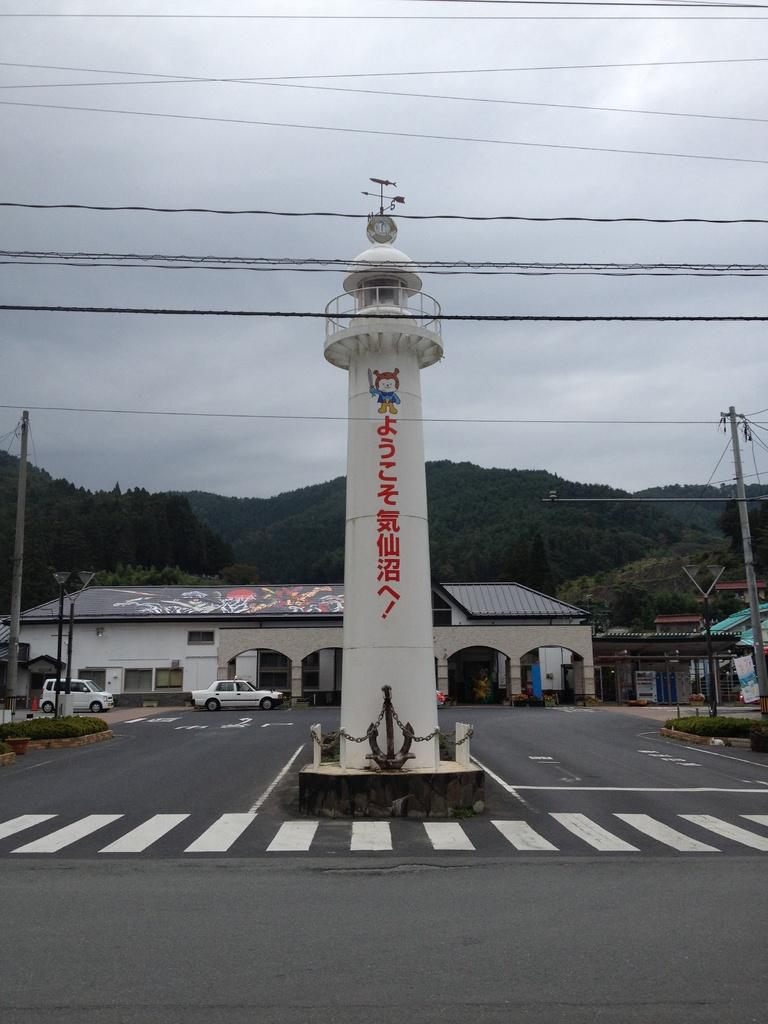What is the main structure in the middle of the image? There is a tower in the middle of the image. What can be seen in the background of the image? In the background of the image, there are poles, cables, lights, buildings, vehicles, and trees. Can you describe the poles in the background? The poles are vertical structures visible in the background of the image. What type of lights are visible in the background? The lights visible in the background are likely streetlights or other illumination sources. How many oranges are being used for arithmetic in the image? There are no oranges or arithmetic activities present in the image. What type of cub is located near the tower in the image? There is no cub present near the tower in the image. 